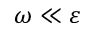Convert formula to latex. <formula><loc_0><loc_0><loc_500><loc_500>\omega \ll \varepsilon</formula> 